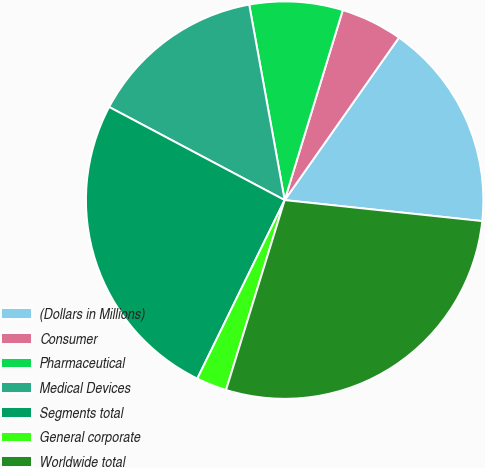Convert chart. <chart><loc_0><loc_0><loc_500><loc_500><pie_chart><fcel>(Dollars in Millions)<fcel>Consumer<fcel>Pharmaceutical<fcel>Medical Devices<fcel>Segments total<fcel>General corporate<fcel>Worldwide total<nl><fcel>16.93%<fcel>5.03%<fcel>7.58%<fcel>14.38%<fcel>25.52%<fcel>2.48%<fcel>28.08%<nl></chart> 